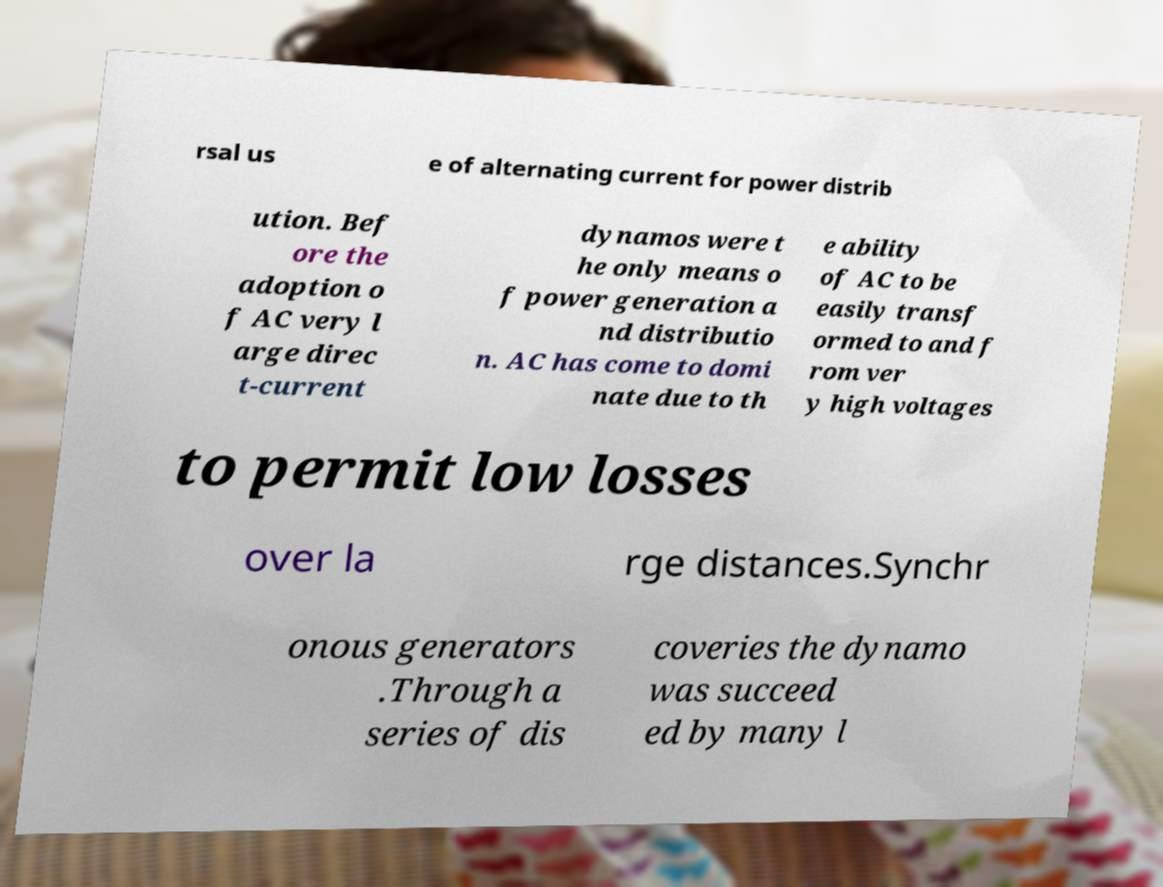I need the written content from this picture converted into text. Can you do that? rsal us e of alternating current for power distrib ution. Bef ore the adoption o f AC very l arge direc t-current dynamos were t he only means o f power generation a nd distributio n. AC has come to domi nate due to th e ability of AC to be easily transf ormed to and f rom ver y high voltages to permit low losses over la rge distances.Synchr onous generators .Through a series of dis coveries the dynamo was succeed ed by many l 